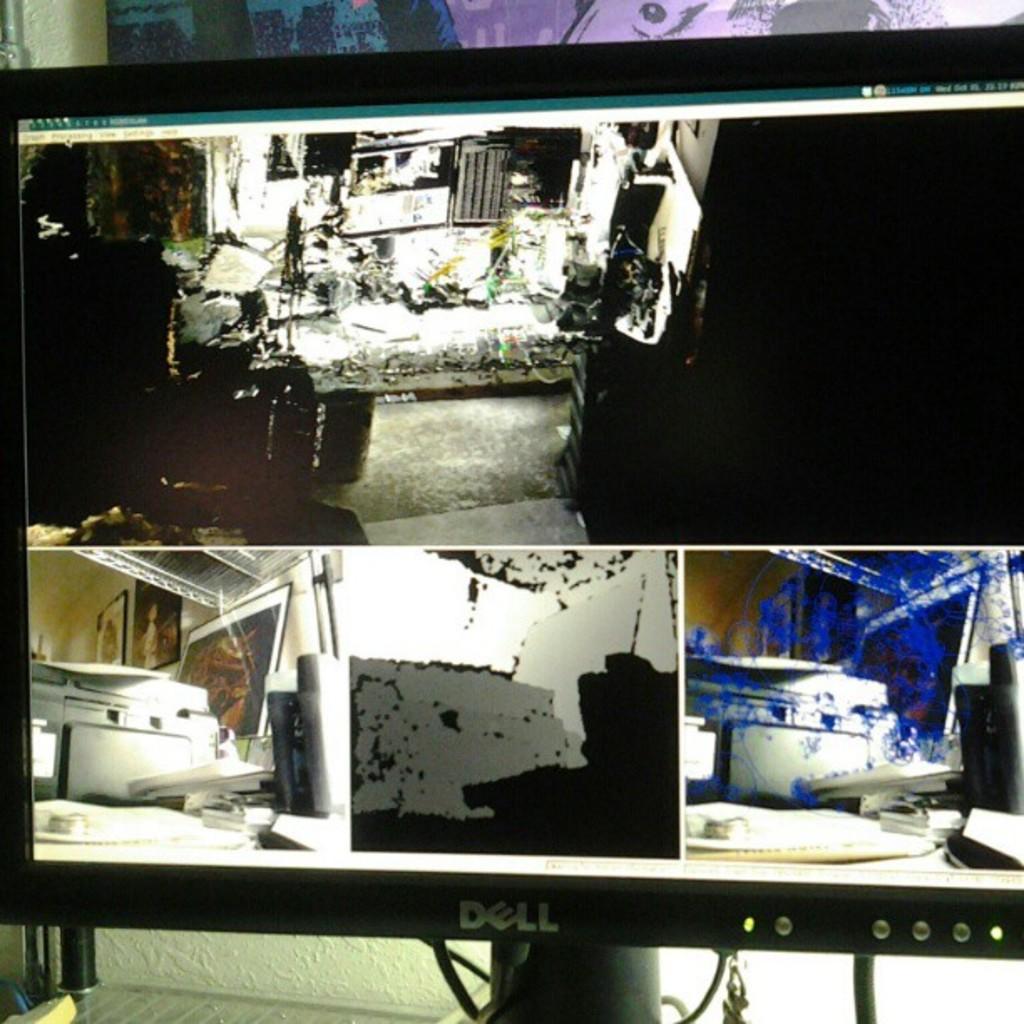What brand is this monitor?
Provide a short and direct response. Dell. 